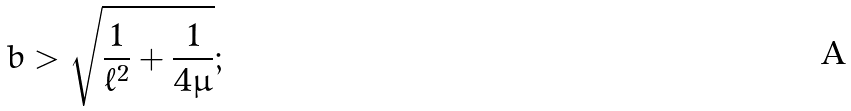Convert formula to latex. <formula><loc_0><loc_0><loc_500><loc_500>b > \sqrt { \frac { 1 } { \ell ^ { 2 } } + \frac { 1 } { 4 \mu } } ;</formula> 